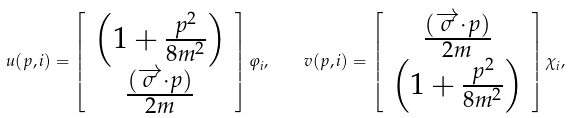<formula> <loc_0><loc_0><loc_500><loc_500>u ( p , i ) = \left [ \begin{array} { c } \left ( 1 + \frac { p ^ { 2 } } { 8 m ^ { 2 } } \right ) \\ \frac { ( \overrightarrow { \sigma } \cdot p ) } { 2 m } \end{array} \right ] \varphi _ { i } , \, \quad v ( p , i ) = \left [ \begin{array} { c } \frac { ( \overrightarrow { \sigma } \cdot p ) } { 2 m } \\ \left ( 1 + \frac { p ^ { 2 } } { 8 m ^ { 2 } } \right ) \end{array} \right ] \chi _ { i } ,</formula> 